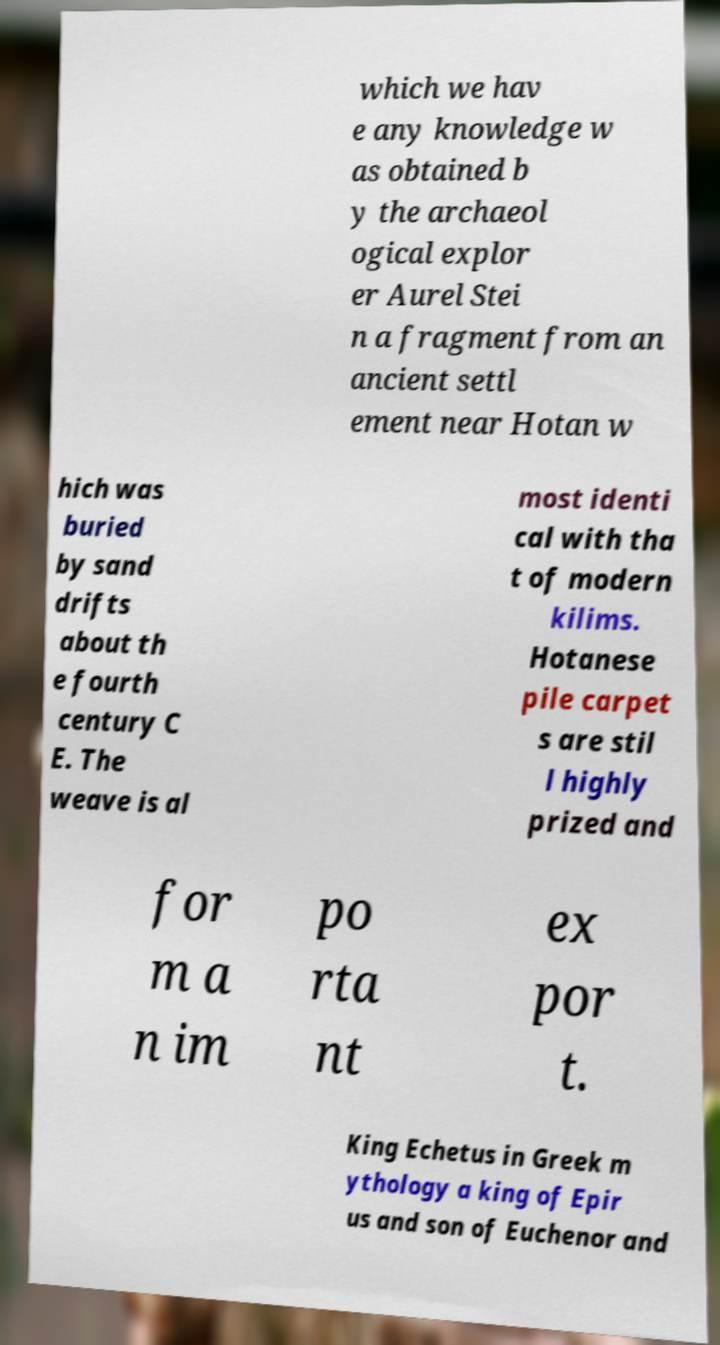For documentation purposes, I need the text within this image transcribed. Could you provide that? which we hav e any knowledge w as obtained b y the archaeol ogical explor er Aurel Stei n a fragment from an ancient settl ement near Hotan w hich was buried by sand drifts about th e fourth century C E. The weave is al most identi cal with tha t of modern kilims. Hotanese pile carpet s are stil l highly prized and for m a n im po rta nt ex por t. King Echetus in Greek m ythology a king of Epir us and son of Euchenor and 